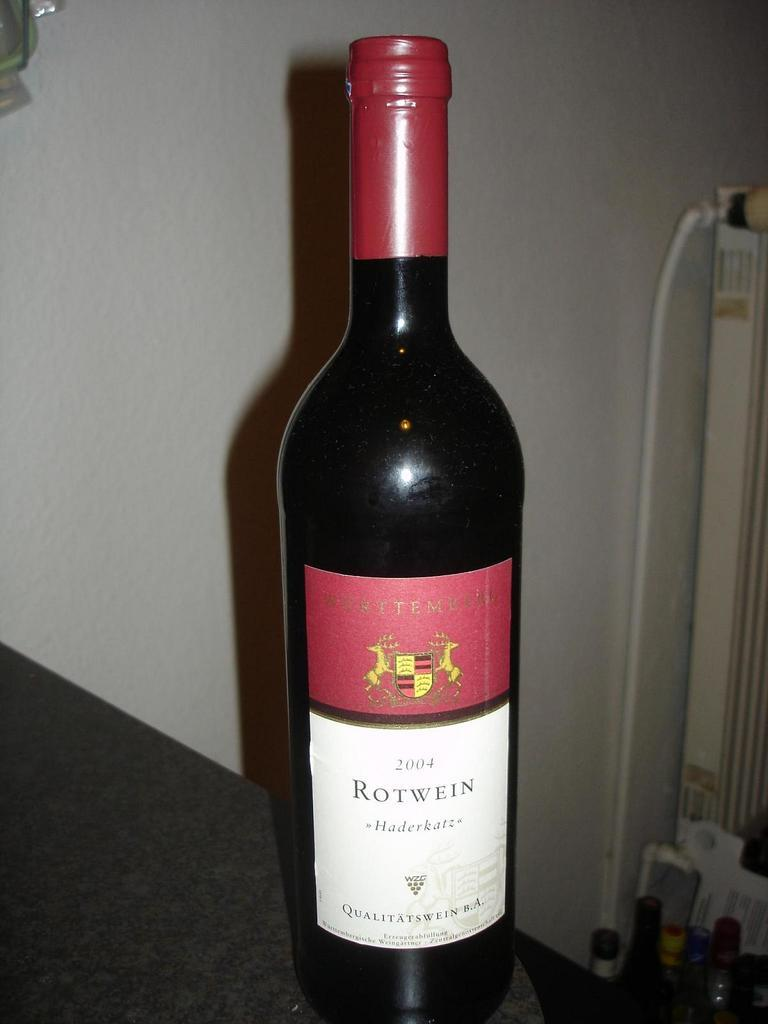<image>
Share a concise interpretation of the image provided. A bottle has the brand name Rotwein on the label. 